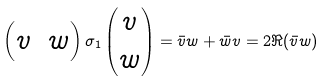Convert formula to latex. <formula><loc_0><loc_0><loc_500><loc_500>\begin{pmatrix} v & w \end{pmatrix} \sigma _ { 1 } \begin{pmatrix} v \\ w \end{pmatrix} = \bar { v } w + \bar { w } v = 2 \Re ( \bar { v } w )</formula> 